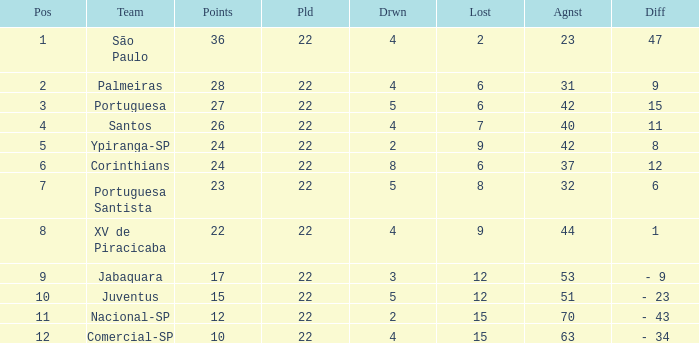Which Against has a Drawn smaller than 5, and a Lost smaller than 6, and a Points larger than 36? 0.0. 